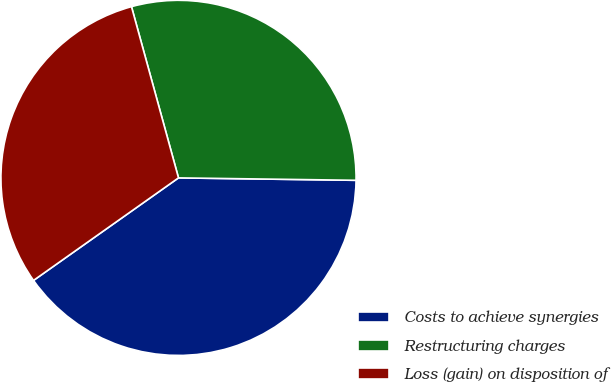Convert chart to OTSL. <chart><loc_0><loc_0><loc_500><loc_500><pie_chart><fcel>Costs to achieve synergies<fcel>Restructuring charges<fcel>Loss (gain) on disposition of<nl><fcel>39.98%<fcel>29.48%<fcel>30.53%<nl></chart> 